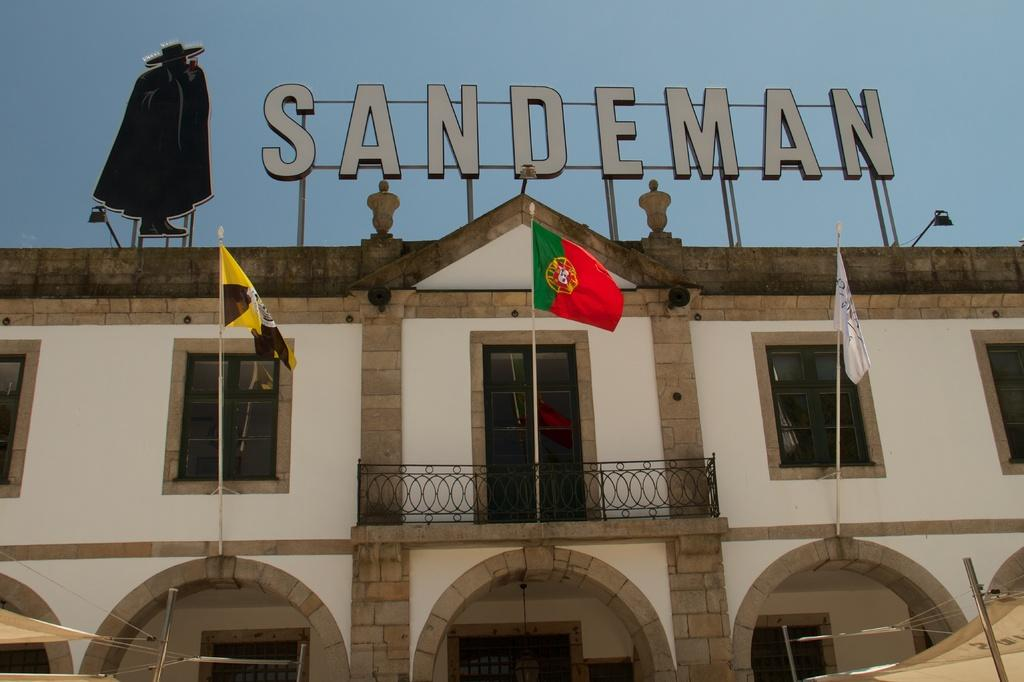What type of structure is present in the image? There is a building in the image. What feature can be seen on the building? The building has metal railing. What are the flags attached to in the image? The flags are on poles in the image. How can the building's interior be observed? The building has windows. What is written or displayed on the sign board in the image? There is a sign board with text in the image. What type of artwork or sculpture is present in the image? There is a statue in the image. What can be seen in the background of the image? The sky is visible in the background of the image. What type of cord is used to connect the base of the statue to the building in the image? There is no cord connecting the base of the statue to the building in the image. The statue is not shown to be connected to the building in any way. 